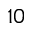<formula> <loc_0><loc_0><loc_500><loc_500>1 0</formula> 